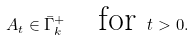Convert formula to latex. <formula><loc_0><loc_0><loc_500><loc_500>A _ { t } \in \bar { \Gamma } _ { k } ^ { + } \quad \text {for } t > 0 .</formula> 